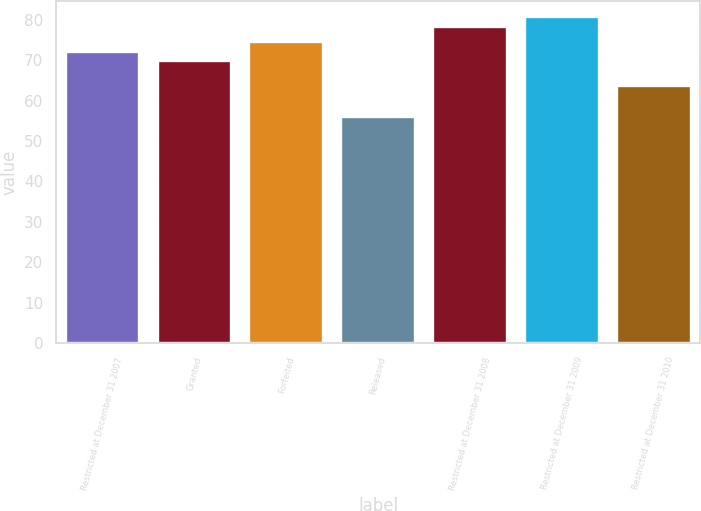Convert chart to OTSL. <chart><loc_0><loc_0><loc_500><loc_500><bar_chart><fcel>Restricted at December 31 2007<fcel>Granted<fcel>Forfeited<fcel>Released<fcel>Restricted at December 31 2008<fcel>Restricted at December 31 2009<fcel>Restricted at December 31 2010<nl><fcel>72.13<fcel>69.76<fcel>74.47<fcel>55.95<fcel>78.28<fcel>80.62<fcel>63.74<nl></chart> 